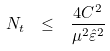<formula> <loc_0><loc_0><loc_500><loc_500>N _ { t } \ \leq \ \frac { 4 C ^ { 2 } } { \mu ^ { 2 } \hat { \varepsilon } ^ { 2 } }</formula> 